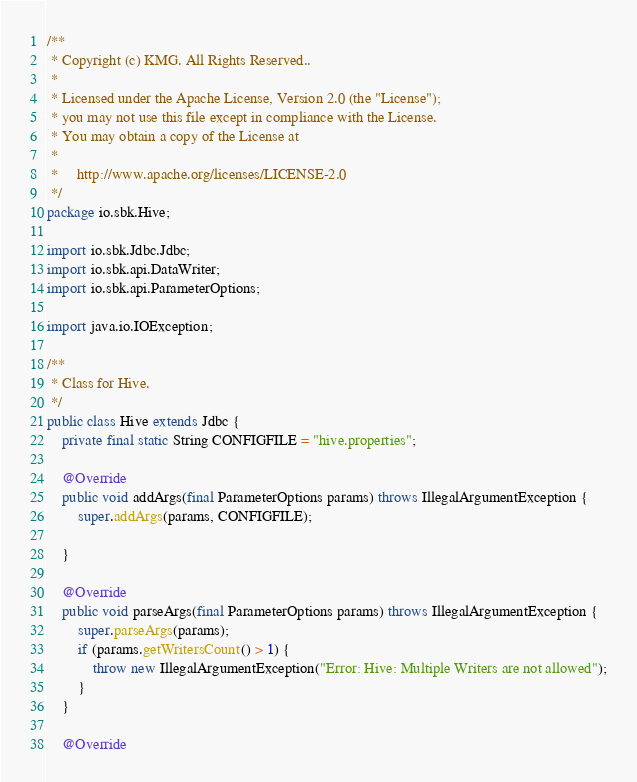<code> <loc_0><loc_0><loc_500><loc_500><_Java_>/**
 * Copyright (c) KMG. All Rights Reserved..
 *
 * Licensed under the Apache License, Version 2.0 (the "License");
 * you may not use this file except in compliance with the License.
 * You may obtain a copy of the License at
 *
 *     http://www.apache.org/licenses/LICENSE-2.0
 */
package io.sbk.Hive;

import io.sbk.Jdbc.Jdbc;
import io.sbk.api.DataWriter;
import io.sbk.api.ParameterOptions;

import java.io.IOException;

/**
 * Class for Hive.
 */
public class Hive extends Jdbc {
    private final static String CONFIGFILE = "hive.properties";

    @Override
    public void addArgs(final ParameterOptions params) throws IllegalArgumentException {
        super.addArgs(params, CONFIGFILE);

    }

    @Override
    public void parseArgs(final ParameterOptions params) throws IllegalArgumentException {
        super.parseArgs(params);
        if (params.getWritersCount() > 1) {
            throw new IllegalArgumentException("Error: Hive: Multiple Writers are not allowed");
        }
    }

    @Override</code> 